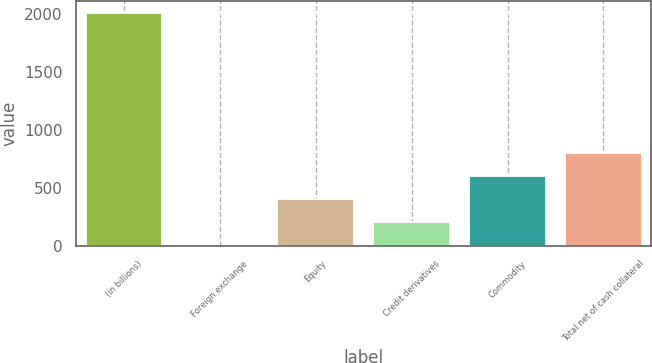<chart> <loc_0><loc_0><loc_500><loc_500><bar_chart><fcel>(in billions)<fcel>Foreign exchange<fcel>Equity<fcel>Credit derivatives<fcel>Commodity<fcel>Total net of cash collateral<nl><fcel>2005<fcel>3<fcel>403.4<fcel>203.2<fcel>603.6<fcel>803.8<nl></chart> 